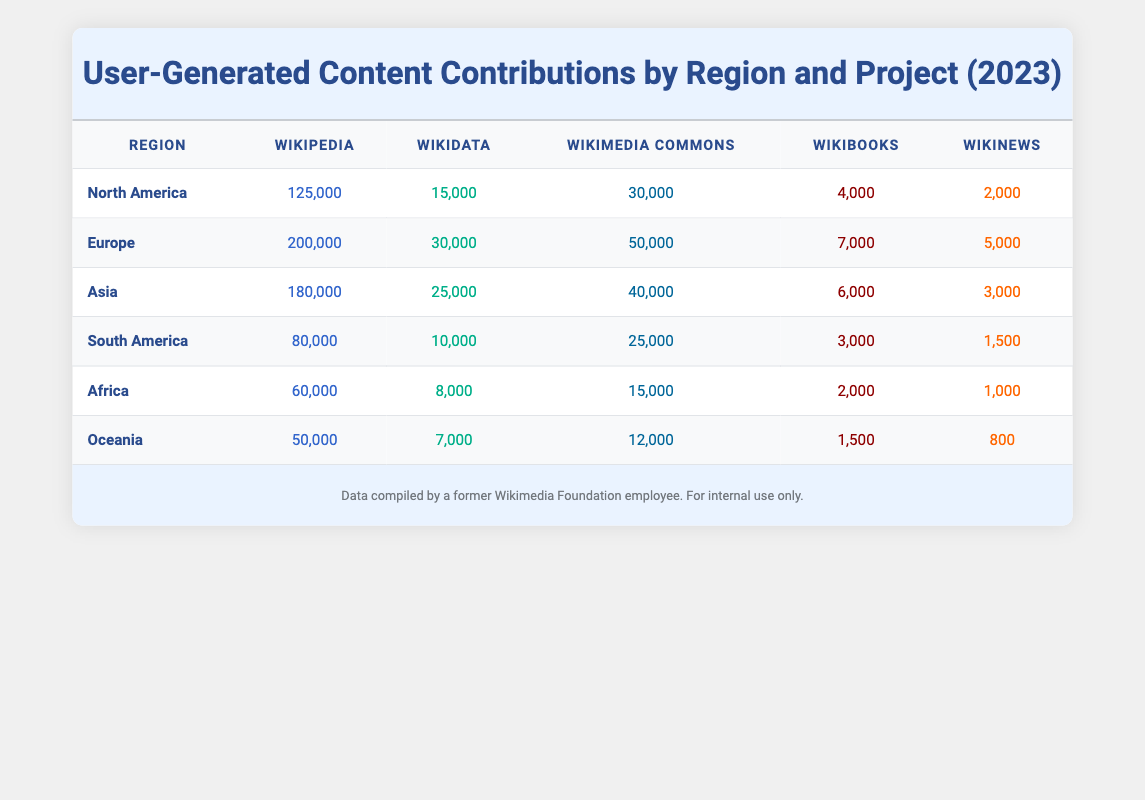What geographical region has the highest number of Wikimedia contributions? By examining the table, we see that Europe has the highest number of contributions across all projects with a total of 200,000 contributions in Wikipedia, along with additional contributions in other categories.
Answer: Europe Which project type received the least contributions from Oceania? Looking at the contributions from Oceania, we find that Wikinews has the least contributions with a total of 800.
Answer: 800 What is the total number of Wikimedia Commons contributions from Africa and South America combined? The contributions to Wikimedia Commons from Africa are 15,000 and from South America are 25,000. Adding these together gives 15,000 + 25,000 = 40,000.
Answer: 40,000 Did North America contribute more to Wikipedia than Asia did in total for all projects? North America contributed 125,000 to Wikipedia while Asia's total contributions for all projects (Wikipedia 180,000 + Wikidata 25,000 + Wikimedia Commons 40,000 + Wikibooks 6,000 + Wikinews 3,000) amount to 254,000, hence Yes, North America did not contribute more in total for all their projects than Asia.
Answer: No What is the difference in the number of contributions to Wikidata between Europe and Africa? From the table, Europe contributed 30,000 to Wikidata, while Africa contributed 8,000. The difference is 30,000 - 8,000 = 22,000.
Answer: 22,000 How many total contributions were made to Wikibooks across all regions? Summing up the Wikibooks contributions: North America 4,000 + Europe 7,000 + Asia 6,000 + South America 3,000 + Africa 2,000 + Oceania 1,500 gives: 4,000 + 7,000 + 6,000 + 3,000 + 2,000 + 1,500 = 23,500.
Answer: 23,500 Which region contributed more to Wikinews, South America or Oceania? The contributions to Wikinews in South America are 1,500, while in Oceania they are 800. Comparing these, South America has higher contributions to Wikinews than Oceania, making it True that South America contributed more.
Answer: Yes What percentage of total contributions came from Asia relative to the total across all regions? First, calculate each region's total contributions: North America (175,000) + Europe (290,000) + Asia (254,000) + South America (118,500) + Africa (86,000) + Oceania (70,500) = 1,000,000 approx. Asia contributed 254,000, thus percentage = (254,000 / 1,000,000) * 100 = 25.4%.
Answer: 25.4% 